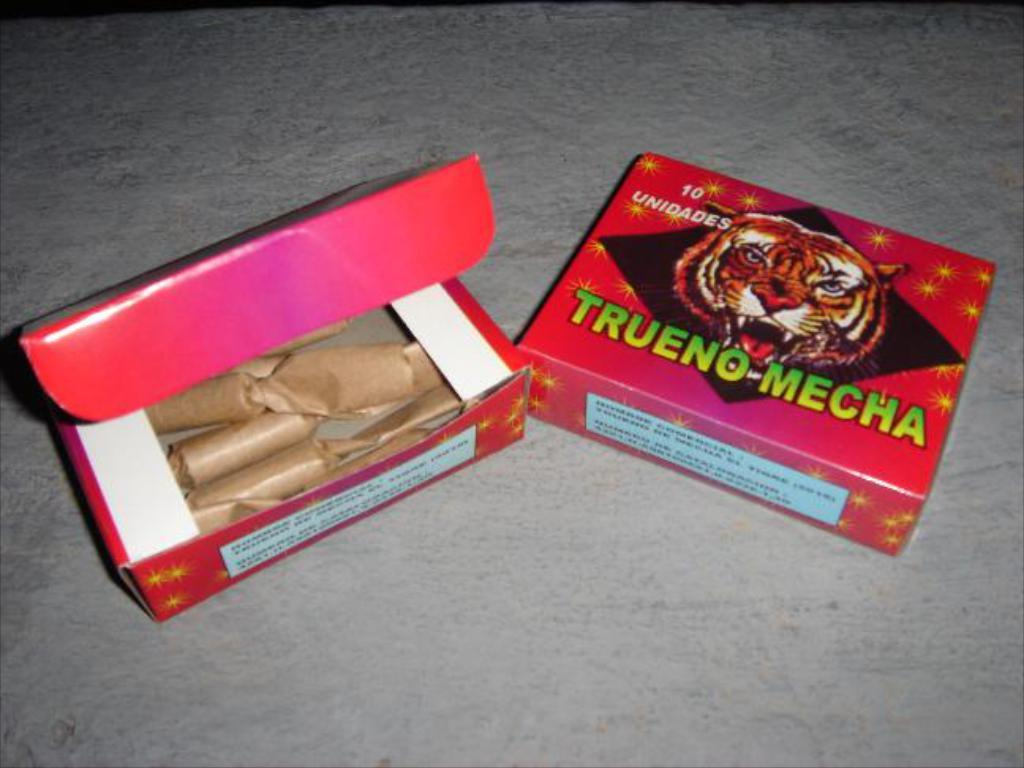Provide a one-sentence caption for the provided image. the word trueno is on a red item. 